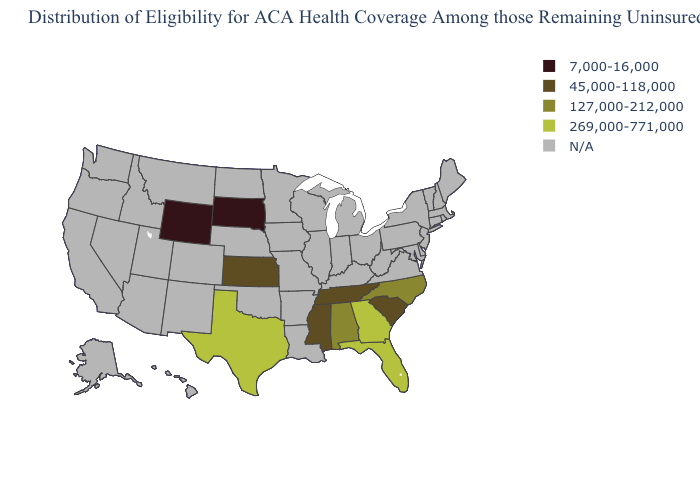What is the value of Arkansas?
Give a very brief answer. N/A. Name the states that have a value in the range 45,000-118,000?
Short answer required. Kansas, Mississippi, South Carolina, Tennessee. Name the states that have a value in the range 45,000-118,000?
Quick response, please. Kansas, Mississippi, South Carolina, Tennessee. What is the highest value in the USA?
Give a very brief answer. 269,000-771,000. Does Georgia have the highest value in the South?
Answer briefly. Yes. What is the value of Vermont?
Answer briefly. N/A. Name the states that have a value in the range 45,000-118,000?
Write a very short answer. Kansas, Mississippi, South Carolina, Tennessee. What is the value of Alaska?
Keep it brief. N/A. What is the value of Washington?
Quick response, please. N/A. Among the states that border Iowa , which have the lowest value?
Be succinct. South Dakota. Name the states that have a value in the range N/A?
Short answer required. Alaska, Arizona, Arkansas, California, Colorado, Connecticut, Delaware, Hawaii, Idaho, Illinois, Indiana, Iowa, Kentucky, Louisiana, Maine, Maryland, Massachusetts, Michigan, Minnesota, Missouri, Montana, Nebraska, Nevada, New Hampshire, New Jersey, New Mexico, New York, North Dakota, Ohio, Oklahoma, Oregon, Pennsylvania, Rhode Island, Utah, Vermont, Virginia, Washington, West Virginia, Wisconsin. What is the value of Utah?
Write a very short answer. N/A. What is the value of Kentucky?
Keep it brief. N/A. Name the states that have a value in the range 45,000-118,000?
Answer briefly. Kansas, Mississippi, South Carolina, Tennessee. 